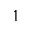Convert formula to latex. <formula><loc_0><loc_0><loc_500><loc_500>1</formula> 